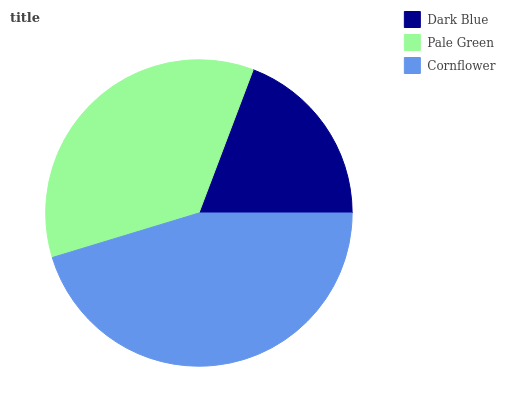Is Dark Blue the minimum?
Answer yes or no. Yes. Is Cornflower the maximum?
Answer yes or no. Yes. Is Pale Green the minimum?
Answer yes or no. No. Is Pale Green the maximum?
Answer yes or no. No. Is Pale Green greater than Dark Blue?
Answer yes or no. Yes. Is Dark Blue less than Pale Green?
Answer yes or no. Yes. Is Dark Blue greater than Pale Green?
Answer yes or no. No. Is Pale Green less than Dark Blue?
Answer yes or no. No. Is Pale Green the high median?
Answer yes or no. Yes. Is Pale Green the low median?
Answer yes or no. Yes. Is Cornflower the high median?
Answer yes or no. No. Is Dark Blue the low median?
Answer yes or no. No. 